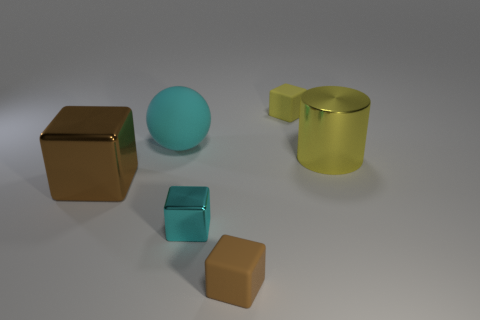Is the color of the block behind the brown metal cube the same as the metallic cylinder?
Give a very brief answer. Yes. There is a thing that is the same color as the cylinder; what shape is it?
Your response must be concise. Cube. There is a tiny rubber object that is on the left side of the small yellow rubber object; is its shape the same as the brown thing that is behind the tiny brown block?
Provide a short and direct response. Yes. There is a yellow object that is the same shape as the brown rubber object; what is its size?
Your answer should be very brief. Small. How many other large yellow cylinders have the same material as the large cylinder?
Provide a succinct answer. 0. What material is the large cyan ball?
Provide a short and direct response. Rubber. What is the shape of the tiny thing on the right side of the small matte thing in front of the yellow cube?
Provide a short and direct response. Cube. The big shiny object on the left side of the small yellow rubber thing has what shape?
Ensure brevity in your answer.  Cube. What number of cubes are the same color as the cylinder?
Give a very brief answer. 1. The large cube has what color?
Provide a succinct answer. Brown. 